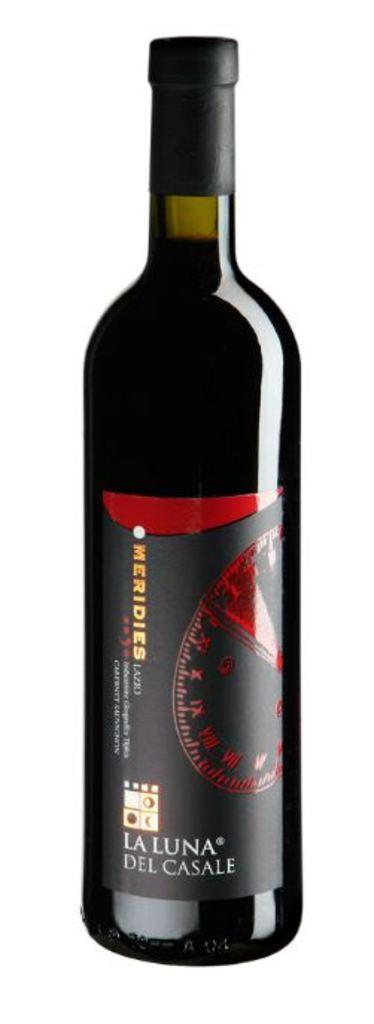What is the main object in the image? There is a wine bottle in the image. What grade does the society give to the wine in the image? There is no mention of a society or a grade in the image, as it only features a wine bottle. 